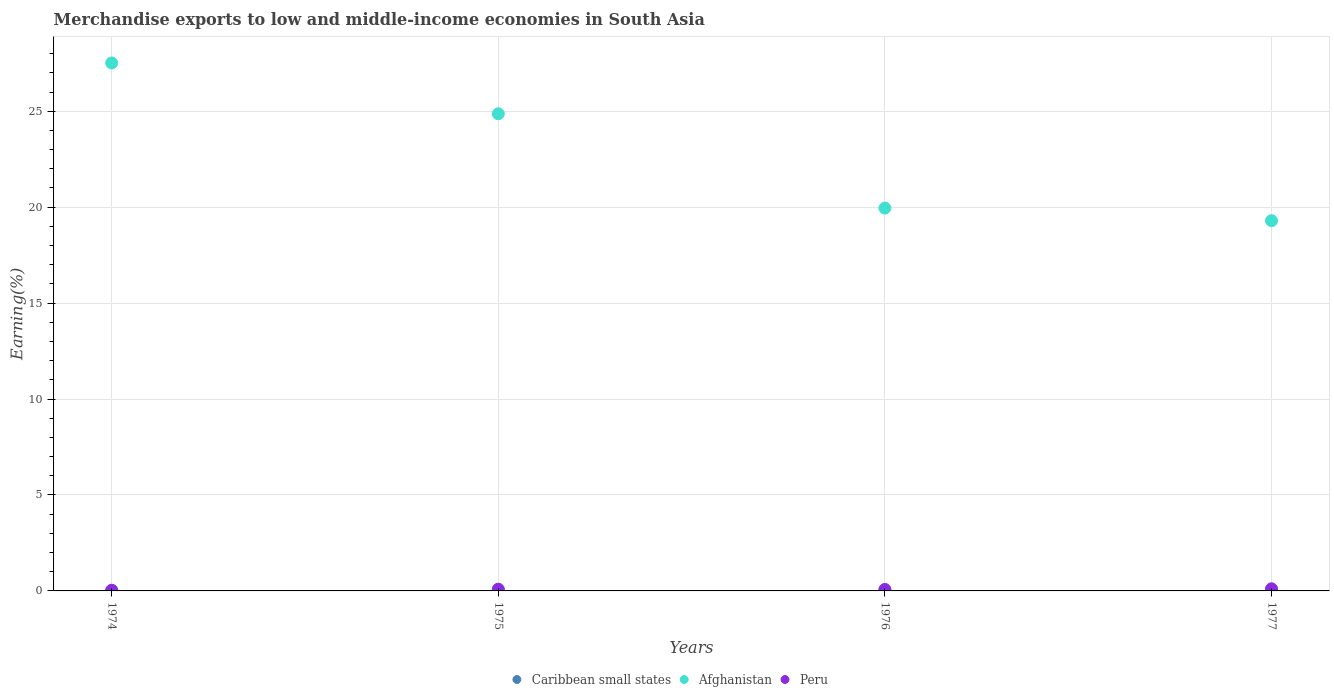How many different coloured dotlines are there?
Give a very brief answer. 3. What is the percentage of amount earned from merchandise exports in Caribbean small states in 1976?
Offer a terse response. 0. Across all years, what is the maximum percentage of amount earned from merchandise exports in Peru?
Provide a short and direct response. 0.11. Across all years, what is the minimum percentage of amount earned from merchandise exports in Afghanistan?
Make the answer very short. 19.29. In which year was the percentage of amount earned from merchandise exports in Caribbean small states maximum?
Keep it short and to the point. 1975. In which year was the percentage of amount earned from merchandise exports in Caribbean small states minimum?
Your response must be concise. 1976. What is the total percentage of amount earned from merchandise exports in Afghanistan in the graph?
Offer a terse response. 91.63. What is the difference between the percentage of amount earned from merchandise exports in Afghanistan in 1975 and that in 1976?
Provide a short and direct response. 4.92. What is the difference between the percentage of amount earned from merchandise exports in Caribbean small states in 1975 and the percentage of amount earned from merchandise exports in Peru in 1974?
Ensure brevity in your answer.  -0.02. What is the average percentage of amount earned from merchandise exports in Afghanistan per year?
Offer a terse response. 22.91. In the year 1976, what is the difference between the percentage of amount earned from merchandise exports in Caribbean small states and percentage of amount earned from merchandise exports in Afghanistan?
Provide a succinct answer. -19.95. What is the ratio of the percentage of amount earned from merchandise exports in Caribbean small states in 1974 to that in 1976?
Offer a very short reply. 1.09. What is the difference between the highest and the second highest percentage of amount earned from merchandise exports in Afghanistan?
Offer a terse response. 2.65. What is the difference between the highest and the lowest percentage of amount earned from merchandise exports in Peru?
Your response must be concise. 0.07. Is it the case that in every year, the sum of the percentage of amount earned from merchandise exports in Afghanistan and percentage of amount earned from merchandise exports in Peru  is greater than the percentage of amount earned from merchandise exports in Caribbean small states?
Give a very brief answer. Yes. Does the percentage of amount earned from merchandise exports in Caribbean small states monotonically increase over the years?
Offer a terse response. No. Is the percentage of amount earned from merchandise exports in Caribbean small states strictly less than the percentage of amount earned from merchandise exports in Afghanistan over the years?
Keep it short and to the point. Yes. What is the difference between two consecutive major ticks on the Y-axis?
Your answer should be very brief. 5. Does the graph contain grids?
Your response must be concise. Yes. Where does the legend appear in the graph?
Your answer should be compact. Bottom center. How are the legend labels stacked?
Provide a succinct answer. Horizontal. What is the title of the graph?
Offer a very short reply. Merchandise exports to low and middle-income economies in South Asia. Does "Malaysia" appear as one of the legend labels in the graph?
Give a very brief answer. No. What is the label or title of the Y-axis?
Provide a succinct answer. Earning(%). What is the Earning(%) in Caribbean small states in 1974?
Keep it short and to the point. 0. What is the Earning(%) of Afghanistan in 1974?
Offer a terse response. 27.51. What is the Earning(%) in Peru in 1974?
Make the answer very short. 0.04. What is the Earning(%) of Caribbean small states in 1975?
Offer a very short reply. 0.01. What is the Earning(%) in Afghanistan in 1975?
Provide a short and direct response. 24.87. What is the Earning(%) in Peru in 1975?
Provide a succinct answer. 0.09. What is the Earning(%) of Caribbean small states in 1976?
Give a very brief answer. 0. What is the Earning(%) in Afghanistan in 1976?
Your answer should be very brief. 19.95. What is the Earning(%) in Peru in 1976?
Provide a succinct answer. 0.08. What is the Earning(%) in Caribbean small states in 1977?
Offer a terse response. 0. What is the Earning(%) of Afghanistan in 1977?
Provide a short and direct response. 19.29. What is the Earning(%) of Peru in 1977?
Your answer should be very brief. 0.11. Across all years, what is the maximum Earning(%) in Caribbean small states?
Ensure brevity in your answer.  0.01. Across all years, what is the maximum Earning(%) of Afghanistan?
Provide a short and direct response. 27.51. Across all years, what is the maximum Earning(%) of Peru?
Offer a very short reply. 0.11. Across all years, what is the minimum Earning(%) of Caribbean small states?
Your answer should be very brief. 0. Across all years, what is the minimum Earning(%) of Afghanistan?
Ensure brevity in your answer.  19.29. Across all years, what is the minimum Earning(%) in Peru?
Your answer should be compact. 0.04. What is the total Earning(%) of Caribbean small states in the graph?
Ensure brevity in your answer.  0.01. What is the total Earning(%) of Afghanistan in the graph?
Offer a very short reply. 91.63. What is the total Earning(%) of Peru in the graph?
Offer a very short reply. 0.31. What is the difference between the Earning(%) in Caribbean small states in 1974 and that in 1975?
Give a very brief answer. -0.01. What is the difference between the Earning(%) of Afghanistan in 1974 and that in 1975?
Keep it short and to the point. 2.65. What is the difference between the Earning(%) of Peru in 1974 and that in 1975?
Keep it short and to the point. -0.05. What is the difference between the Earning(%) in Afghanistan in 1974 and that in 1976?
Your response must be concise. 7.56. What is the difference between the Earning(%) of Peru in 1974 and that in 1976?
Your response must be concise. -0.04. What is the difference between the Earning(%) of Caribbean small states in 1974 and that in 1977?
Offer a terse response. -0. What is the difference between the Earning(%) of Afghanistan in 1974 and that in 1977?
Your response must be concise. 8.22. What is the difference between the Earning(%) of Peru in 1974 and that in 1977?
Make the answer very short. -0.07. What is the difference between the Earning(%) of Caribbean small states in 1975 and that in 1976?
Your response must be concise. 0.01. What is the difference between the Earning(%) of Afghanistan in 1975 and that in 1976?
Your answer should be compact. 4.92. What is the difference between the Earning(%) in Peru in 1975 and that in 1976?
Offer a terse response. 0.01. What is the difference between the Earning(%) of Caribbean small states in 1975 and that in 1977?
Provide a short and direct response. 0.01. What is the difference between the Earning(%) of Afghanistan in 1975 and that in 1977?
Provide a short and direct response. 5.57. What is the difference between the Earning(%) of Peru in 1975 and that in 1977?
Keep it short and to the point. -0.02. What is the difference between the Earning(%) in Caribbean small states in 1976 and that in 1977?
Your answer should be compact. -0. What is the difference between the Earning(%) in Afghanistan in 1976 and that in 1977?
Your answer should be very brief. 0.66. What is the difference between the Earning(%) of Peru in 1976 and that in 1977?
Your answer should be very brief. -0.03. What is the difference between the Earning(%) of Caribbean small states in 1974 and the Earning(%) of Afghanistan in 1975?
Give a very brief answer. -24.87. What is the difference between the Earning(%) in Caribbean small states in 1974 and the Earning(%) in Peru in 1975?
Offer a very short reply. -0.09. What is the difference between the Earning(%) of Afghanistan in 1974 and the Earning(%) of Peru in 1975?
Make the answer very short. 27.42. What is the difference between the Earning(%) of Caribbean small states in 1974 and the Earning(%) of Afghanistan in 1976?
Your response must be concise. -19.95. What is the difference between the Earning(%) of Caribbean small states in 1974 and the Earning(%) of Peru in 1976?
Give a very brief answer. -0.08. What is the difference between the Earning(%) of Afghanistan in 1974 and the Earning(%) of Peru in 1976?
Offer a terse response. 27.44. What is the difference between the Earning(%) of Caribbean small states in 1974 and the Earning(%) of Afghanistan in 1977?
Provide a succinct answer. -19.29. What is the difference between the Earning(%) of Caribbean small states in 1974 and the Earning(%) of Peru in 1977?
Make the answer very short. -0.11. What is the difference between the Earning(%) in Afghanistan in 1974 and the Earning(%) in Peru in 1977?
Make the answer very short. 27.4. What is the difference between the Earning(%) in Caribbean small states in 1975 and the Earning(%) in Afghanistan in 1976?
Your response must be concise. -19.94. What is the difference between the Earning(%) of Caribbean small states in 1975 and the Earning(%) of Peru in 1976?
Provide a succinct answer. -0.06. What is the difference between the Earning(%) in Afghanistan in 1975 and the Earning(%) in Peru in 1976?
Your answer should be compact. 24.79. What is the difference between the Earning(%) of Caribbean small states in 1975 and the Earning(%) of Afghanistan in 1977?
Your answer should be very brief. -19.28. What is the difference between the Earning(%) of Caribbean small states in 1975 and the Earning(%) of Peru in 1977?
Offer a very short reply. -0.1. What is the difference between the Earning(%) in Afghanistan in 1975 and the Earning(%) in Peru in 1977?
Your answer should be compact. 24.76. What is the difference between the Earning(%) of Caribbean small states in 1976 and the Earning(%) of Afghanistan in 1977?
Offer a terse response. -19.29. What is the difference between the Earning(%) of Caribbean small states in 1976 and the Earning(%) of Peru in 1977?
Your response must be concise. -0.11. What is the difference between the Earning(%) in Afghanistan in 1976 and the Earning(%) in Peru in 1977?
Your answer should be very brief. 19.84. What is the average Earning(%) in Caribbean small states per year?
Provide a succinct answer. 0. What is the average Earning(%) in Afghanistan per year?
Your response must be concise. 22.91. What is the average Earning(%) of Peru per year?
Provide a short and direct response. 0.08. In the year 1974, what is the difference between the Earning(%) in Caribbean small states and Earning(%) in Afghanistan?
Ensure brevity in your answer.  -27.51. In the year 1974, what is the difference between the Earning(%) of Caribbean small states and Earning(%) of Peru?
Provide a succinct answer. -0.04. In the year 1974, what is the difference between the Earning(%) of Afghanistan and Earning(%) of Peru?
Your response must be concise. 27.48. In the year 1975, what is the difference between the Earning(%) of Caribbean small states and Earning(%) of Afghanistan?
Give a very brief answer. -24.85. In the year 1975, what is the difference between the Earning(%) of Caribbean small states and Earning(%) of Peru?
Provide a succinct answer. -0.08. In the year 1975, what is the difference between the Earning(%) in Afghanistan and Earning(%) in Peru?
Provide a succinct answer. 24.78. In the year 1976, what is the difference between the Earning(%) in Caribbean small states and Earning(%) in Afghanistan?
Your response must be concise. -19.95. In the year 1976, what is the difference between the Earning(%) of Caribbean small states and Earning(%) of Peru?
Keep it short and to the point. -0.08. In the year 1976, what is the difference between the Earning(%) in Afghanistan and Earning(%) in Peru?
Your answer should be compact. 19.87. In the year 1977, what is the difference between the Earning(%) in Caribbean small states and Earning(%) in Afghanistan?
Offer a terse response. -19.29. In the year 1977, what is the difference between the Earning(%) of Caribbean small states and Earning(%) of Peru?
Offer a very short reply. -0.11. In the year 1977, what is the difference between the Earning(%) of Afghanistan and Earning(%) of Peru?
Provide a short and direct response. 19.18. What is the ratio of the Earning(%) of Caribbean small states in 1974 to that in 1975?
Keep it short and to the point. 0.07. What is the ratio of the Earning(%) of Afghanistan in 1974 to that in 1975?
Your answer should be very brief. 1.11. What is the ratio of the Earning(%) of Peru in 1974 to that in 1975?
Offer a very short reply. 0.41. What is the ratio of the Earning(%) of Caribbean small states in 1974 to that in 1976?
Offer a very short reply. 1.09. What is the ratio of the Earning(%) in Afghanistan in 1974 to that in 1976?
Provide a succinct answer. 1.38. What is the ratio of the Earning(%) of Peru in 1974 to that in 1976?
Your answer should be very brief. 0.48. What is the ratio of the Earning(%) of Caribbean small states in 1974 to that in 1977?
Make the answer very short. 0.65. What is the ratio of the Earning(%) of Afghanistan in 1974 to that in 1977?
Ensure brevity in your answer.  1.43. What is the ratio of the Earning(%) of Peru in 1974 to that in 1977?
Make the answer very short. 0.33. What is the ratio of the Earning(%) of Caribbean small states in 1975 to that in 1976?
Keep it short and to the point. 15.88. What is the ratio of the Earning(%) in Afghanistan in 1975 to that in 1976?
Your answer should be compact. 1.25. What is the ratio of the Earning(%) in Peru in 1975 to that in 1976?
Keep it short and to the point. 1.17. What is the ratio of the Earning(%) of Caribbean small states in 1975 to that in 1977?
Your response must be concise. 9.43. What is the ratio of the Earning(%) of Afghanistan in 1975 to that in 1977?
Provide a short and direct response. 1.29. What is the ratio of the Earning(%) of Peru in 1975 to that in 1977?
Ensure brevity in your answer.  0.81. What is the ratio of the Earning(%) in Caribbean small states in 1976 to that in 1977?
Keep it short and to the point. 0.59. What is the ratio of the Earning(%) in Afghanistan in 1976 to that in 1977?
Your answer should be compact. 1.03. What is the ratio of the Earning(%) of Peru in 1976 to that in 1977?
Ensure brevity in your answer.  0.69. What is the difference between the highest and the second highest Earning(%) in Caribbean small states?
Give a very brief answer. 0.01. What is the difference between the highest and the second highest Earning(%) in Afghanistan?
Your answer should be compact. 2.65. What is the difference between the highest and the second highest Earning(%) of Peru?
Offer a terse response. 0.02. What is the difference between the highest and the lowest Earning(%) of Caribbean small states?
Offer a very short reply. 0.01. What is the difference between the highest and the lowest Earning(%) of Afghanistan?
Your answer should be very brief. 8.22. What is the difference between the highest and the lowest Earning(%) in Peru?
Your answer should be compact. 0.07. 